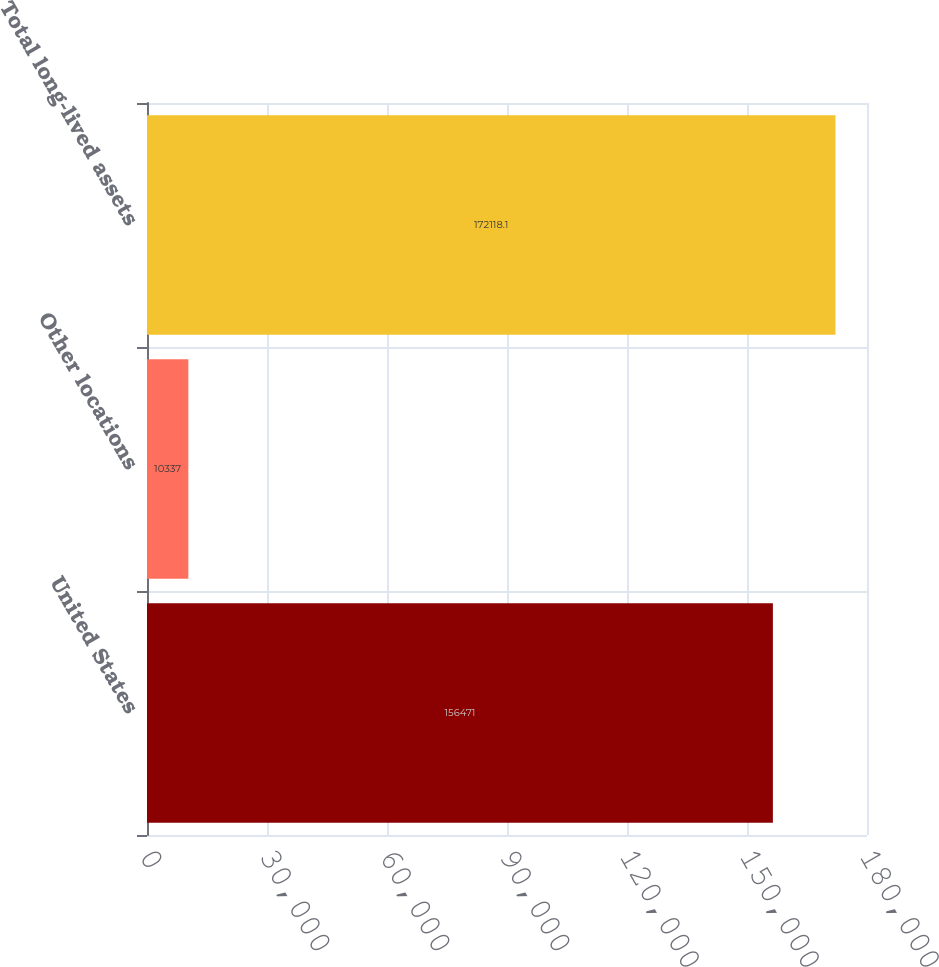<chart> <loc_0><loc_0><loc_500><loc_500><bar_chart><fcel>United States<fcel>Other locations<fcel>Total long-lived assets<nl><fcel>156471<fcel>10337<fcel>172118<nl></chart> 